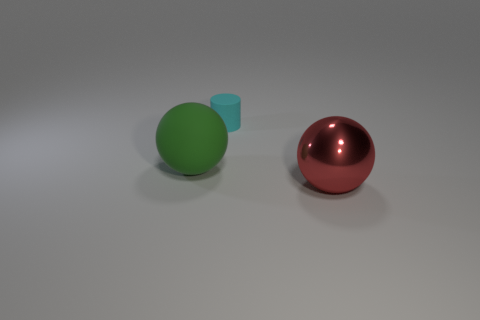There is a large ball that is right of the large ball left of the big red metal object; is there a rubber sphere in front of it?
Offer a very short reply. No. Are there any large metal things on the left side of the small cyan cylinder?
Your response must be concise. No. How many objects are the same color as the matte sphere?
Your answer should be compact. 0. What is the size of the cyan cylinder that is the same material as the large green sphere?
Your response must be concise. Small. What is the size of the thing that is behind the big ball that is to the left of the large thing that is in front of the green matte sphere?
Your answer should be very brief. Small. What size is the ball right of the big rubber object?
Ensure brevity in your answer.  Large. How many green things are either large metal balls or balls?
Your answer should be very brief. 1. Is there a cyan cylinder that has the same size as the green object?
Ensure brevity in your answer.  No. There is a green sphere that is the same size as the red metal object; what is it made of?
Provide a short and direct response. Rubber. There is a green rubber sphere behind the metallic object; does it have the same size as the thing that is in front of the green sphere?
Keep it short and to the point. Yes. 